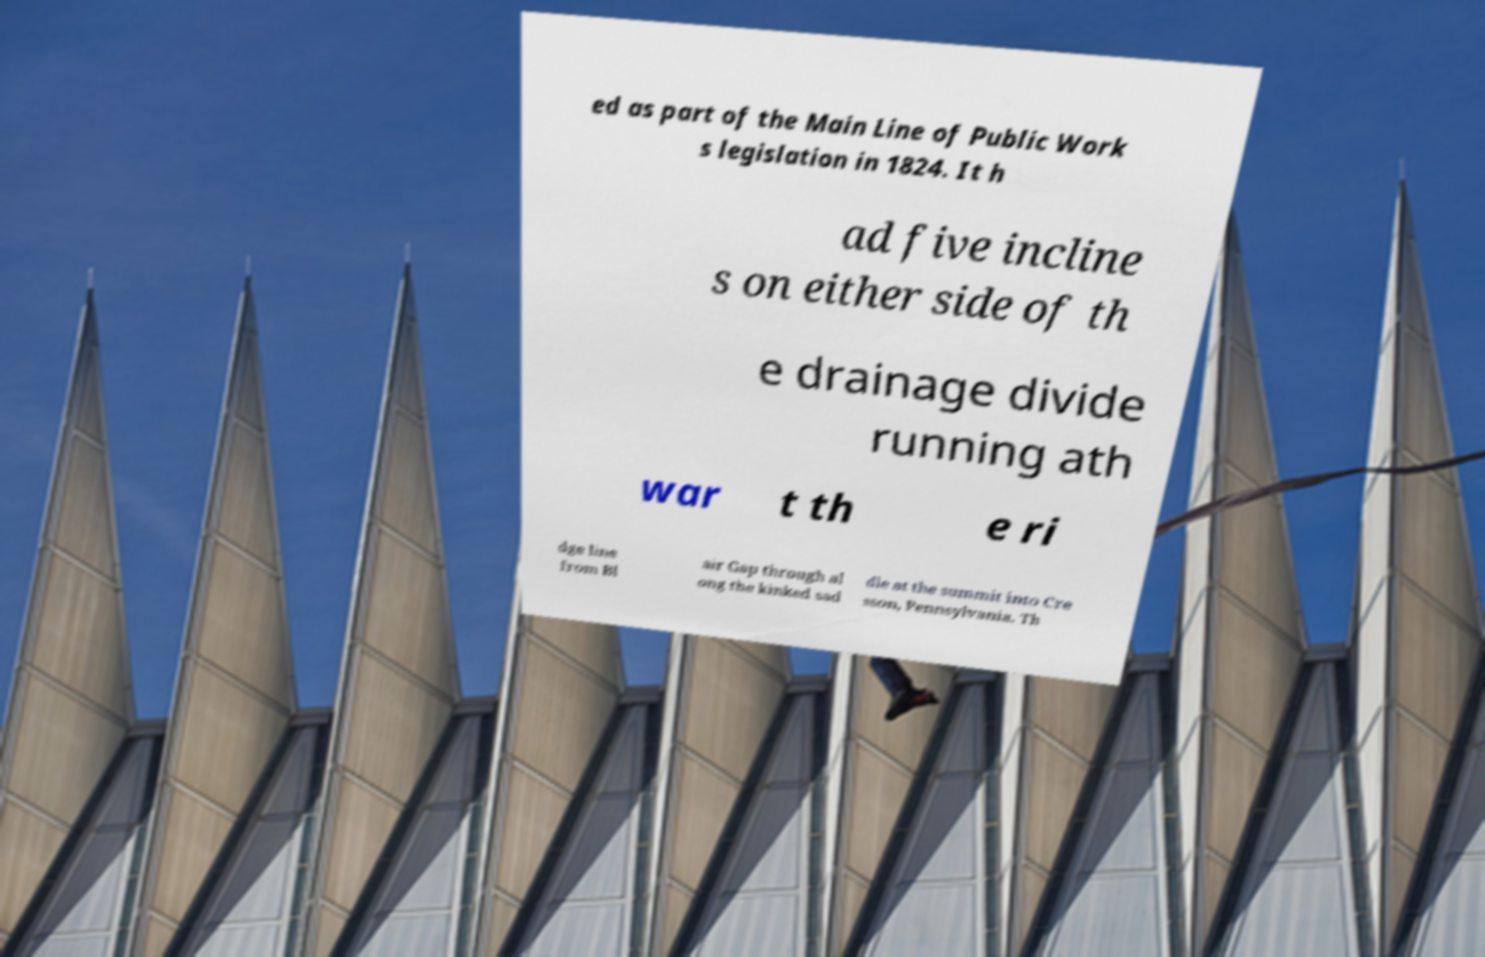I need the written content from this picture converted into text. Can you do that? ed as part of the Main Line of Public Work s legislation in 1824. It h ad five incline s on either side of th e drainage divide running ath war t th e ri dge line from Bl air Gap through al ong the kinked sad dle at the summit into Cre sson, Pennsylvania. Th 